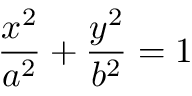Convert formula to latex. <formula><loc_0><loc_0><loc_500><loc_500>\frac { x ^ { 2 } } { a ^ { 2 } } + \frac { y ^ { 2 } } { b ^ { 2 } } = 1</formula> 